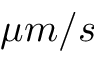Convert formula to latex. <formula><loc_0><loc_0><loc_500><loc_500>\mu m / s</formula> 